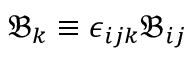Convert formula to latex. <formula><loc_0><loc_0><loc_500><loc_500>\mathfrak { B } _ { k } \equiv \epsilon _ { i j k } \mathfrak { B } _ { i j }</formula> 